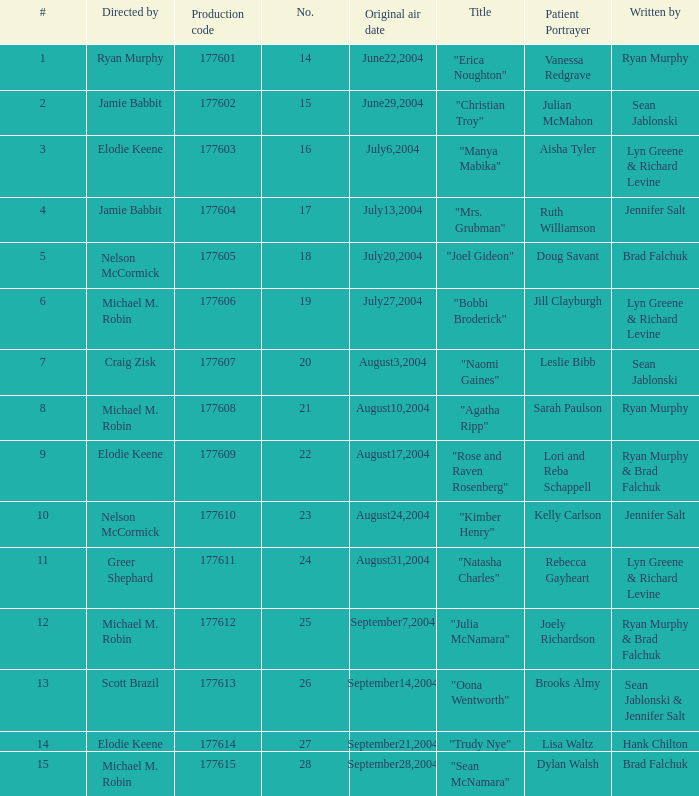How many episodes are numbered 4 in the season? 1.0. 